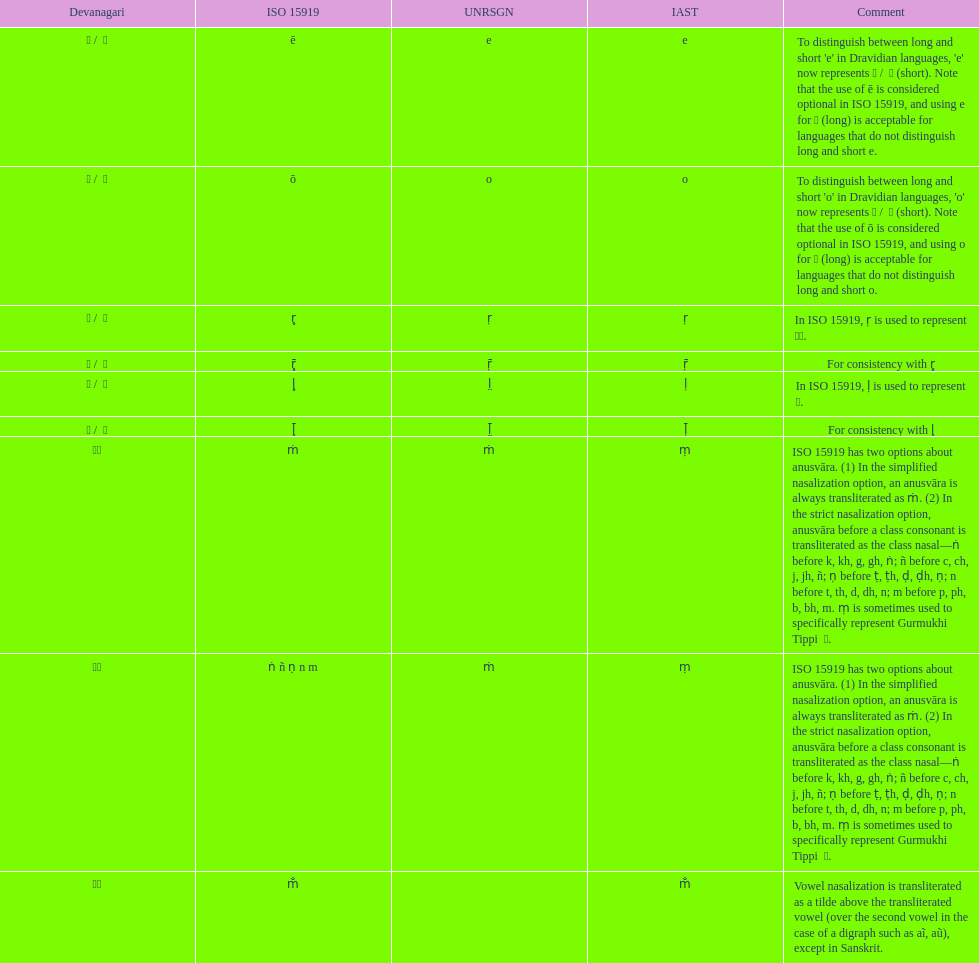What iast is mentioned prior to the o? E. 